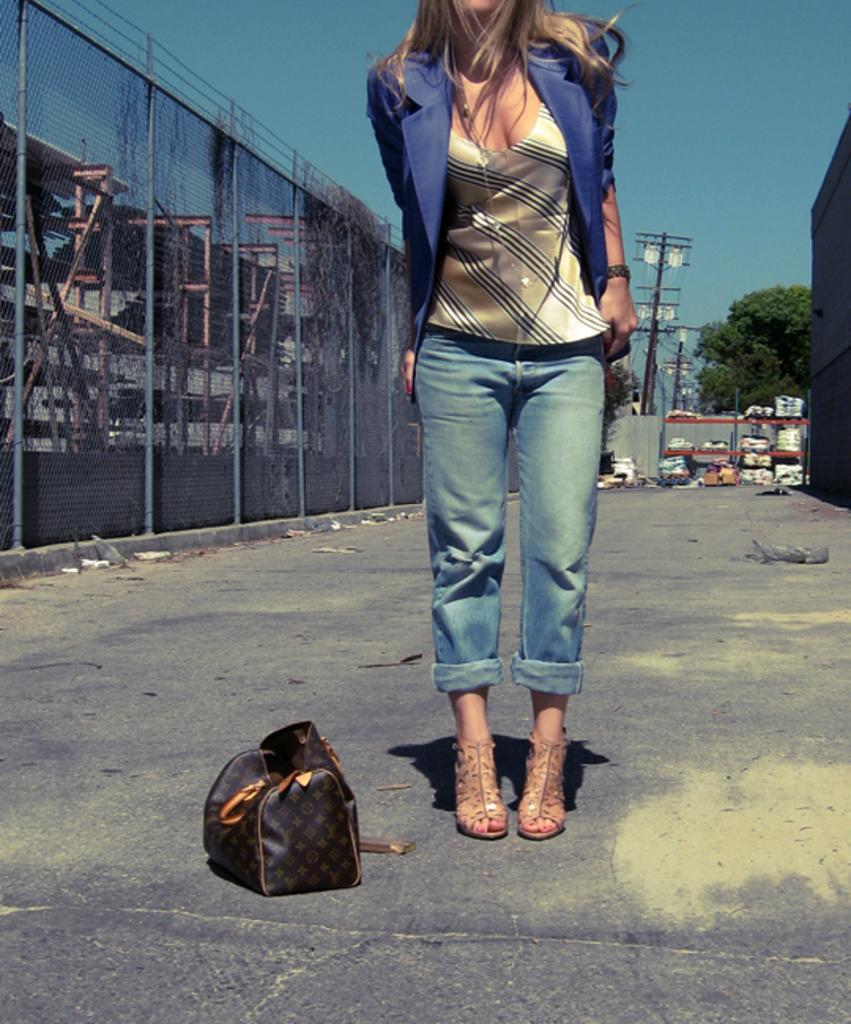What is the woman in the image doing? The woman is standing in the image. What is the woman holding in the image? The woman is holding a bag. Where is the woman standing in the image? The woman is standing on a road. What can be seen in the background of the image? There is sky, a pole, a tree, bags, and iron grills visible in the background of the image. What type of donkey can be seen interacting with the woman in the image? There is no donkey present in the image; the woman is standing alone on the road. What date is marked on the calendar in the image? There is no calendar present in the image. 